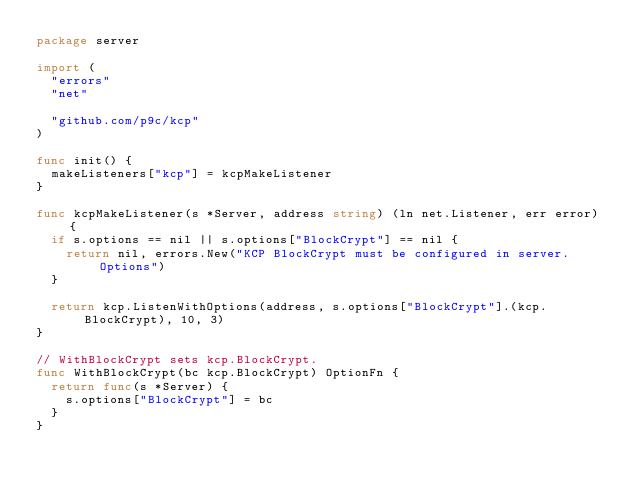<code> <loc_0><loc_0><loc_500><loc_500><_Go_>package server

import (
	"errors"
	"net"

	"github.com/p9c/kcp"
)

func init() {
	makeListeners["kcp"] = kcpMakeListener
}

func kcpMakeListener(s *Server, address string) (ln net.Listener, err error) {
	if s.options == nil || s.options["BlockCrypt"] == nil {
		return nil, errors.New("KCP BlockCrypt must be configured in server.Options")
	}

	return kcp.ListenWithOptions(address, s.options["BlockCrypt"].(kcp.BlockCrypt), 10, 3)
}

// WithBlockCrypt sets kcp.BlockCrypt.
func WithBlockCrypt(bc kcp.BlockCrypt) OptionFn {
	return func(s *Server) {
		s.options["BlockCrypt"] = bc
	}
}
</code> 